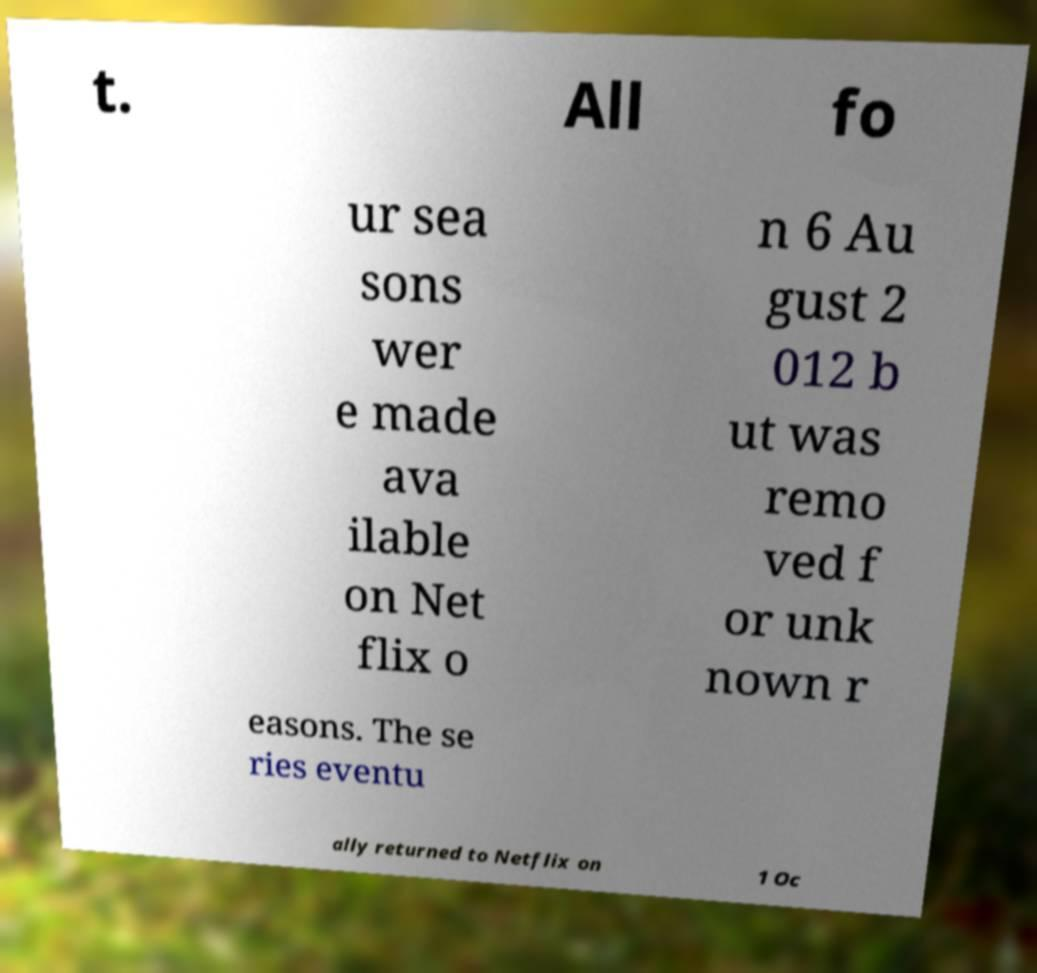Could you extract and type out the text from this image? t. All fo ur sea sons wer e made ava ilable on Net flix o n 6 Au gust 2 012 b ut was remo ved f or unk nown r easons. The se ries eventu ally returned to Netflix on 1 Oc 